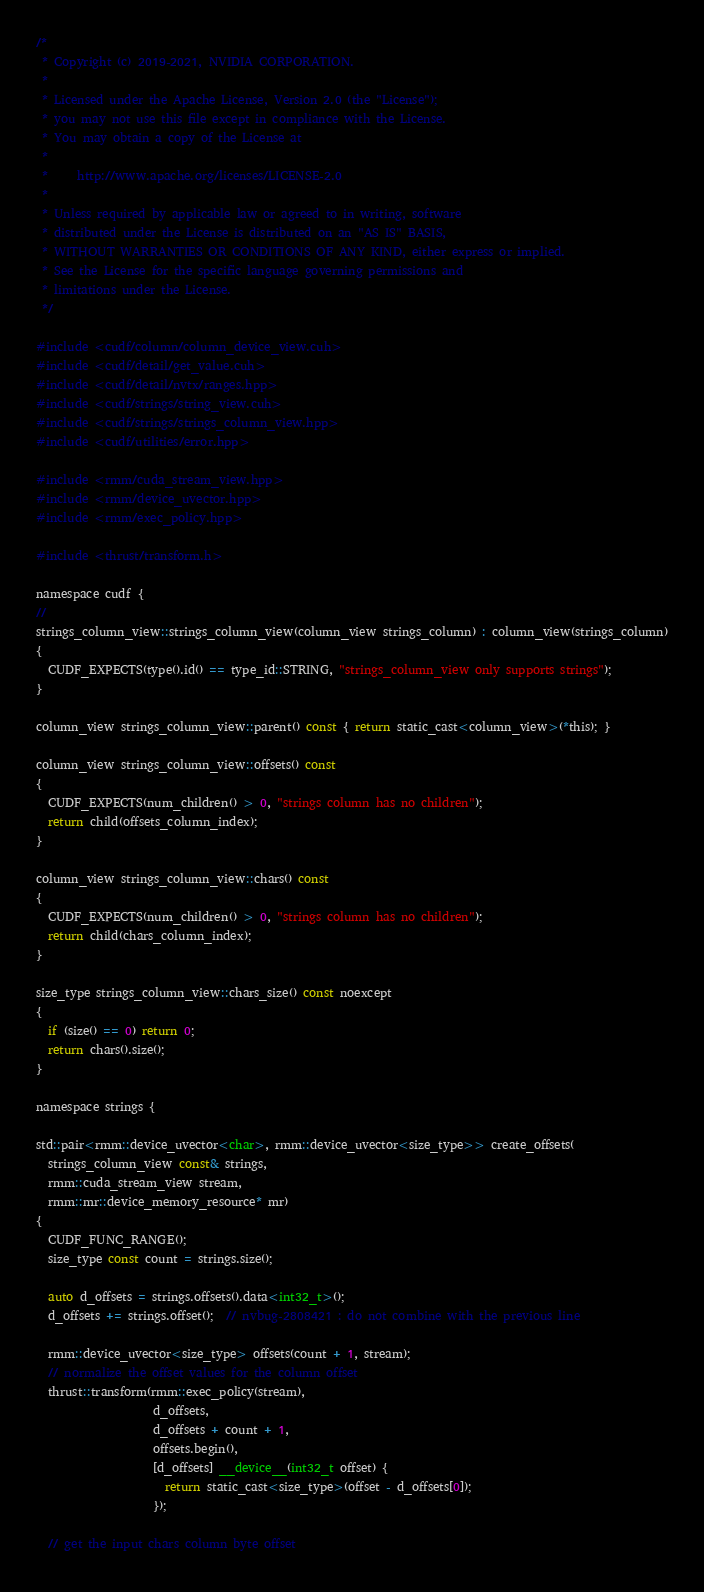Convert code to text. <code><loc_0><loc_0><loc_500><loc_500><_Cuda_>/*
 * Copyright (c) 2019-2021, NVIDIA CORPORATION.
 *
 * Licensed under the Apache License, Version 2.0 (the "License");
 * you may not use this file except in compliance with the License.
 * You may obtain a copy of the License at
 *
 *     http://www.apache.org/licenses/LICENSE-2.0
 *
 * Unless required by applicable law or agreed to in writing, software
 * distributed under the License is distributed on an "AS IS" BASIS,
 * WITHOUT WARRANTIES OR CONDITIONS OF ANY KIND, either express or implied.
 * See the License for the specific language governing permissions and
 * limitations under the License.
 */

#include <cudf/column/column_device_view.cuh>
#include <cudf/detail/get_value.cuh>
#include <cudf/detail/nvtx/ranges.hpp>
#include <cudf/strings/string_view.cuh>
#include <cudf/strings/strings_column_view.hpp>
#include <cudf/utilities/error.hpp>

#include <rmm/cuda_stream_view.hpp>
#include <rmm/device_uvector.hpp>
#include <rmm/exec_policy.hpp>

#include <thrust/transform.h>

namespace cudf {
//
strings_column_view::strings_column_view(column_view strings_column) : column_view(strings_column)
{
  CUDF_EXPECTS(type().id() == type_id::STRING, "strings_column_view only supports strings");
}

column_view strings_column_view::parent() const { return static_cast<column_view>(*this); }

column_view strings_column_view::offsets() const
{
  CUDF_EXPECTS(num_children() > 0, "strings column has no children");
  return child(offsets_column_index);
}

column_view strings_column_view::chars() const
{
  CUDF_EXPECTS(num_children() > 0, "strings column has no children");
  return child(chars_column_index);
}

size_type strings_column_view::chars_size() const noexcept
{
  if (size() == 0) return 0;
  return chars().size();
}

namespace strings {

std::pair<rmm::device_uvector<char>, rmm::device_uvector<size_type>> create_offsets(
  strings_column_view const& strings,
  rmm::cuda_stream_view stream,
  rmm::mr::device_memory_resource* mr)
{
  CUDF_FUNC_RANGE();
  size_type const count = strings.size();

  auto d_offsets = strings.offsets().data<int32_t>();
  d_offsets += strings.offset();  // nvbug-2808421 : do not combine with the previous line

  rmm::device_uvector<size_type> offsets(count + 1, stream);
  // normalize the offset values for the column offset
  thrust::transform(rmm::exec_policy(stream),
                    d_offsets,
                    d_offsets + count + 1,
                    offsets.begin(),
                    [d_offsets] __device__(int32_t offset) {
                      return static_cast<size_type>(offset - d_offsets[0]);
                    });

  // get the input chars column byte offset</code> 